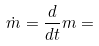<formula> <loc_0><loc_0><loc_500><loc_500>\dot { m } = \frac { d } { d t } m =</formula> 